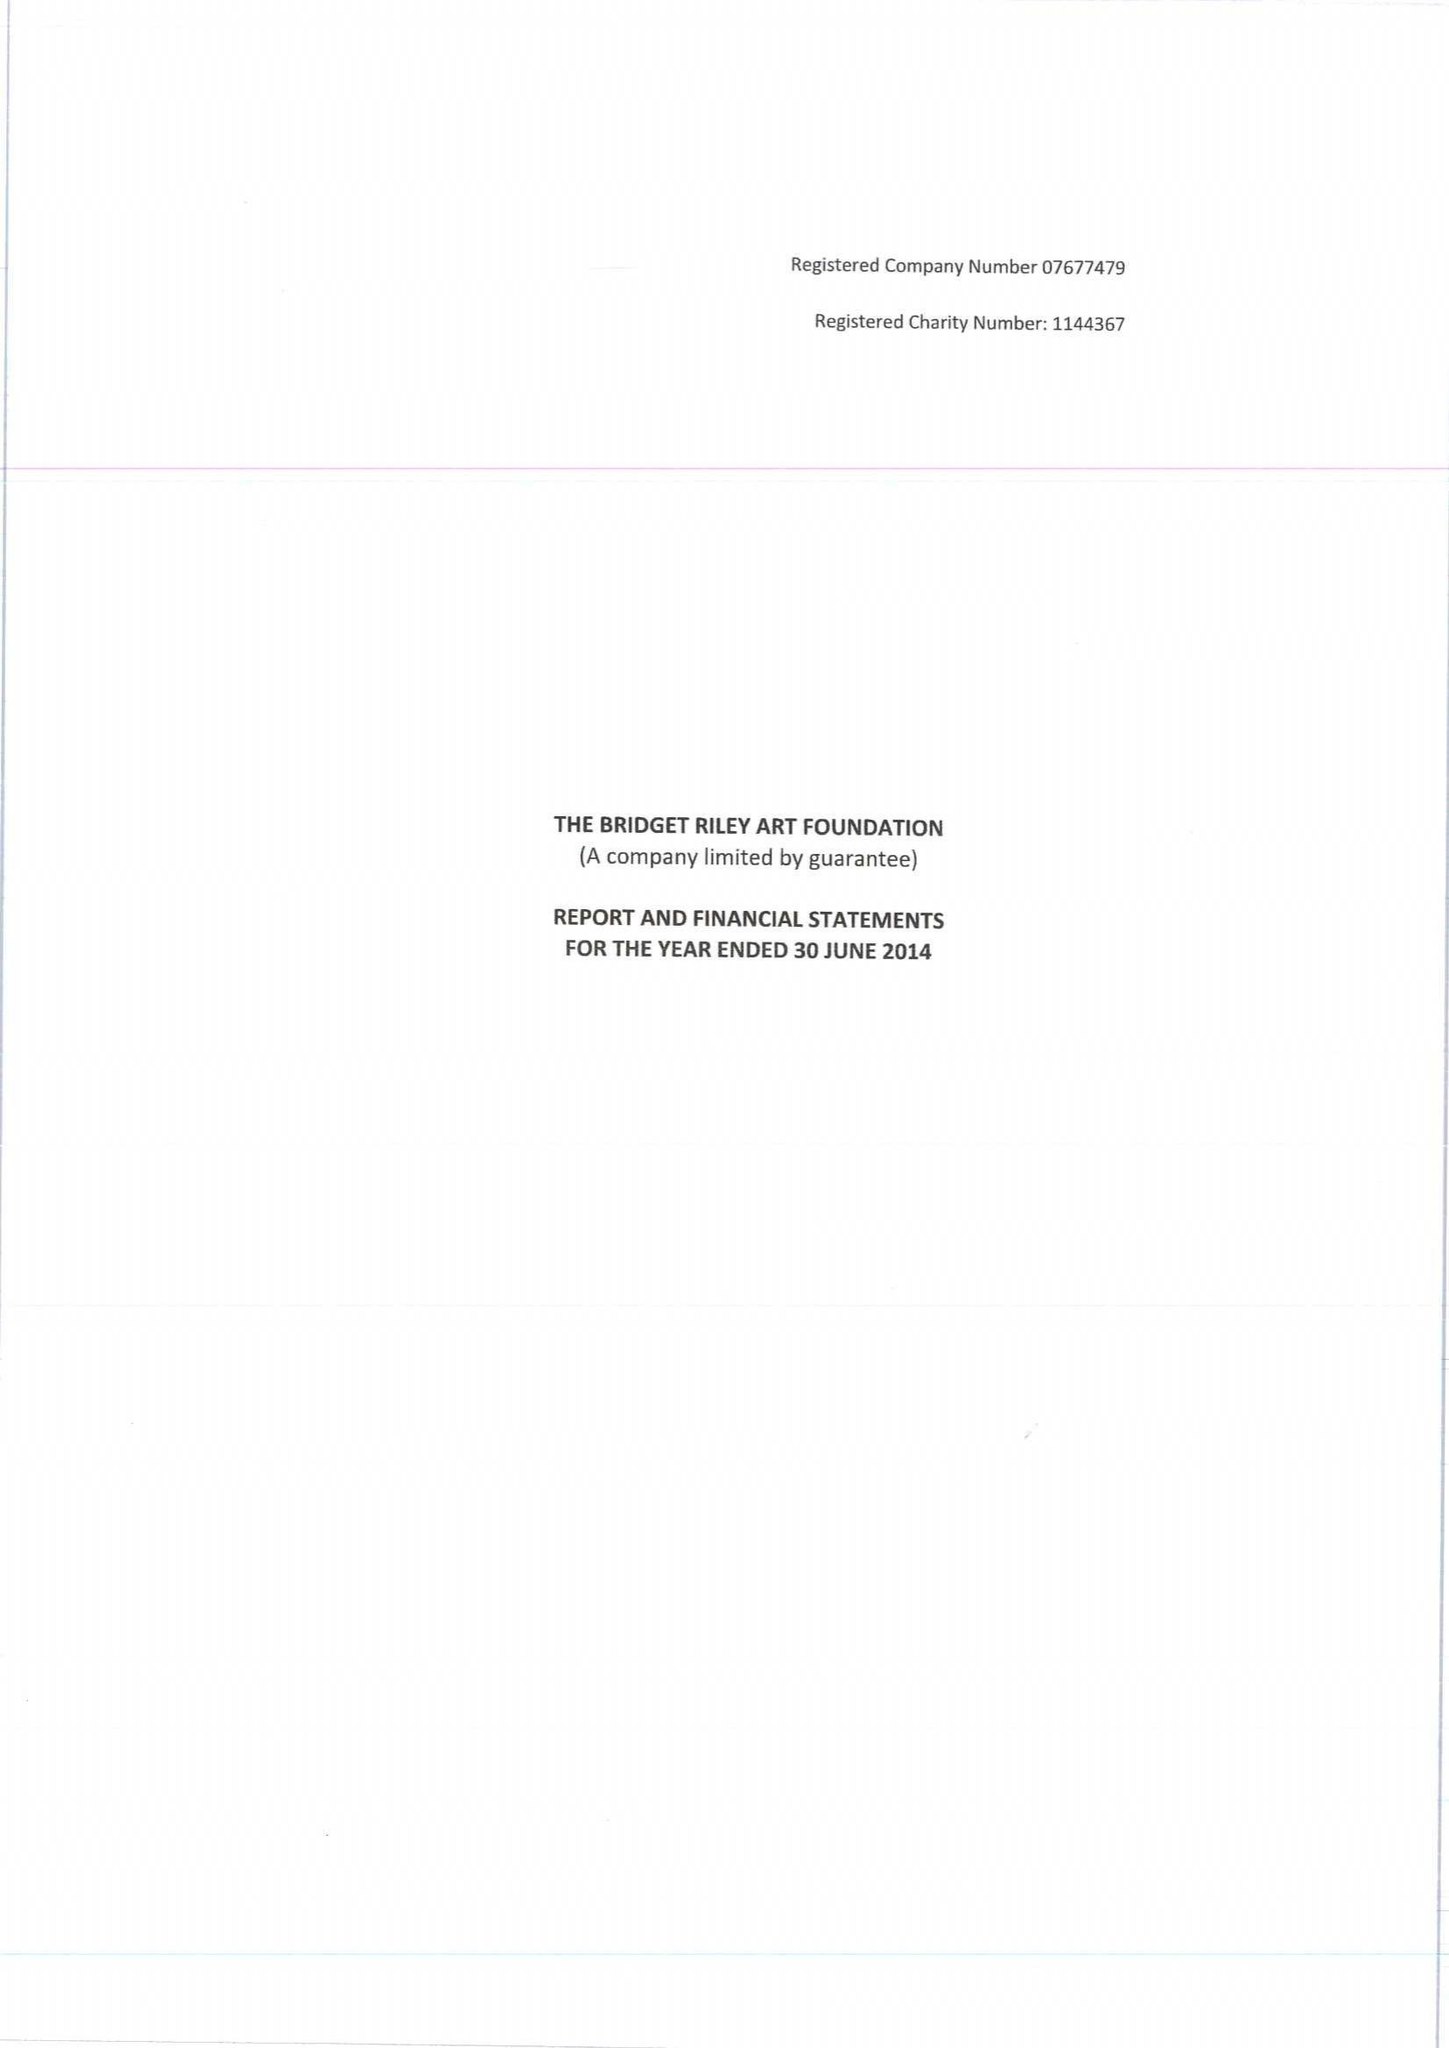What is the value for the address__street_line?
Answer the question using a single word or phrase. 7 ROYAL CRESCENT 